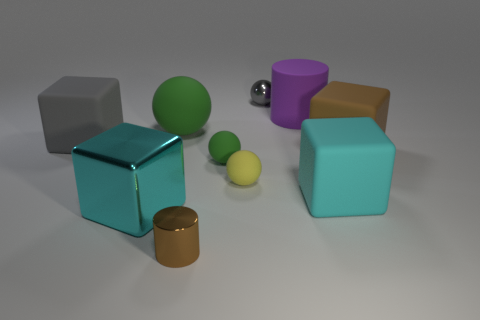Subtract 1 spheres. How many spheres are left? 3 Subtract all brown blocks. How many blocks are left? 3 Subtract all purple spheres. Subtract all green cylinders. How many spheres are left? 4 Subtract all blocks. How many objects are left? 6 Add 8 yellow spheres. How many yellow spheres exist? 9 Subtract 1 brown cubes. How many objects are left? 9 Subtract all brown matte cubes. Subtract all cubes. How many objects are left? 5 Add 2 shiny cubes. How many shiny cubes are left? 3 